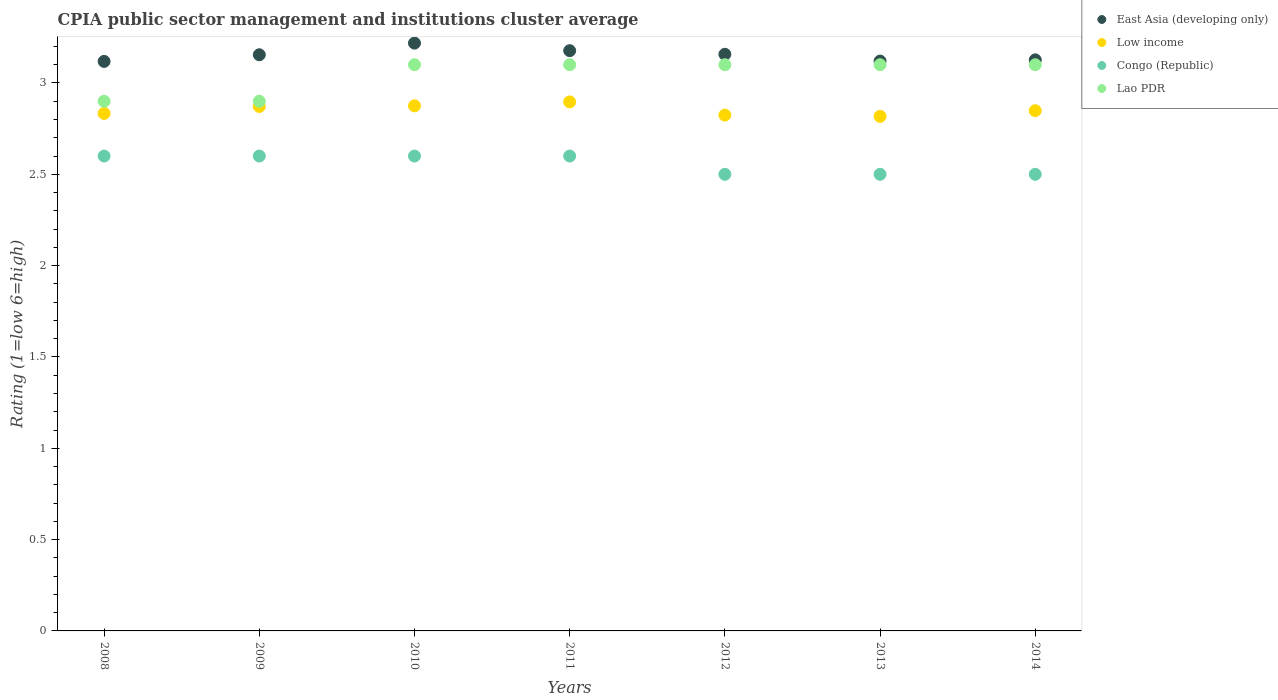How many different coloured dotlines are there?
Offer a terse response. 4. Is the number of dotlines equal to the number of legend labels?
Keep it short and to the point. Yes. What is the CPIA rating in Low income in 2011?
Ensure brevity in your answer.  2.9. Across all years, what is the maximum CPIA rating in Low income?
Give a very brief answer. 2.9. Across all years, what is the minimum CPIA rating in Low income?
Your answer should be compact. 2.82. In which year was the CPIA rating in Congo (Republic) maximum?
Ensure brevity in your answer.  2008. What is the total CPIA rating in Congo (Republic) in the graph?
Give a very brief answer. 17.9. What is the difference between the CPIA rating in East Asia (developing only) in 2011 and that in 2013?
Your response must be concise. 0.06. What is the difference between the CPIA rating in East Asia (developing only) in 2013 and the CPIA rating in Lao PDR in 2009?
Ensure brevity in your answer.  0.22. What is the average CPIA rating in Congo (Republic) per year?
Offer a terse response. 2.56. In the year 2014, what is the difference between the CPIA rating in Congo (Republic) and CPIA rating in Lao PDR?
Your response must be concise. -0.6. In how many years, is the CPIA rating in Lao PDR greater than 1.7?
Give a very brief answer. 7. What is the ratio of the CPIA rating in East Asia (developing only) in 2009 to that in 2014?
Your answer should be compact. 1.01. Is the difference between the CPIA rating in Congo (Republic) in 2008 and 2011 greater than the difference between the CPIA rating in Lao PDR in 2008 and 2011?
Offer a terse response. Yes. What is the difference between the highest and the second highest CPIA rating in East Asia (developing only)?
Offer a very short reply. 0.04. What is the difference between the highest and the lowest CPIA rating in Lao PDR?
Provide a succinct answer. 0.2. Is the sum of the CPIA rating in Low income in 2010 and 2013 greater than the maximum CPIA rating in Congo (Republic) across all years?
Your answer should be compact. Yes. Is it the case that in every year, the sum of the CPIA rating in Low income and CPIA rating in East Asia (developing only)  is greater than the sum of CPIA rating in Lao PDR and CPIA rating in Congo (Republic)?
Provide a short and direct response. No. Is it the case that in every year, the sum of the CPIA rating in Lao PDR and CPIA rating in Congo (Republic)  is greater than the CPIA rating in Low income?
Your response must be concise. Yes. How many years are there in the graph?
Offer a very short reply. 7. What is the difference between two consecutive major ticks on the Y-axis?
Give a very brief answer. 0.5. Are the values on the major ticks of Y-axis written in scientific E-notation?
Your answer should be very brief. No. Does the graph contain grids?
Keep it short and to the point. No. How many legend labels are there?
Make the answer very short. 4. What is the title of the graph?
Make the answer very short. CPIA public sector management and institutions cluster average. Does "San Marino" appear as one of the legend labels in the graph?
Keep it short and to the point. No. What is the Rating (1=low 6=high) in East Asia (developing only) in 2008?
Give a very brief answer. 3.12. What is the Rating (1=low 6=high) of Low income in 2008?
Provide a short and direct response. 2.83. What is the Rating (1=low 6=high) in East Asia (developing only) in 2009?
Keep it short and to the point. 3.15. What is the Rating (1=low 6=high) of Low income in 2009?
Give a very brief answer. 2.87. What is the Rating (1=low 6=high) of Lao PDR in 2009?
Give a very brief answer. 2.9. What is the Rating (1=low 6=high) in East Asia (developing only) in 2010?
Offer a terse response. 3.22. What is the Rating (1=low 6=high) of Low income in 2010?
Offer a terse response. 2.88. What is the Rating (1=low 6=high) in Congo (Republic) in 2010?
Provide a succinct answer. 2.6. What is the Rating (1=low 6=high) of Lao PDR in 2010?
Ensure brevity in your answer.  3.1. What is the Rating (1=low 6=high) of East Asia (developing only) in 2011?
Make the answer very short. 3.18. What is the Rating (1=low 6=high) of Low income in 2011?
Your answer should be compact. 2.9. What is the Rating (1=low 6=high) of Congo (Republic) in 2011?
Keep it short and to the point. 2.6. What is the Rating (1=low 6=high) in East Asia (developing only) in 2012?
Make the answer very short. 3.16. What is the Rating (1=low 6=high) of Low income in 2012?
Provide a short and direct response. 2.82. What is the Rating (1=low 6=high) in Lao PDR in 2012?
Your answer should be compact. 3.1. What is the Rating (1=low 6=high) in East Asia (developing only) in 2013?
Keep it short and to the point. 3.12. What is the Rating (1=low 6=high) of Low income in 2013?
Your response must be concise. 2.82. What is the Rating (1=low 6=high) of East Asia (developing only) in 2014?
Your answer should be very brief. 3.13. What is the Rating (1=low 6=high) in Low income in 2014?
Provide a succinct answer. 2.85. What is the Rating (1=low 6=high) in Congo (Republic) in 2014?
Your answer should be very brief. 2.5. What is the Rating (1=low 6=high) of Lao PDR in 2014?
Your answer should be compact. 3.1. Across all years, what is the maximum Rating (1=low 6=high) of East Asia (developing only)?
Your response must be concise. 3.22. Across all years, what is the maximum Rating (1=low 6=high) of Low income?
Give a very brief answer. 2.9. Across all years, what is the maximum Rating (1=low 6=high) of Congo (Republic)?
Your answer should be very brief. 2.6. Across all years, what is the maximum Rating (1=low 6=high) of Lao PDR?
Your answer should be compact. 3.1. Across all years, what is the minimum Rating (1=low 6=high) in East Asia (developing only)?
Your answer should be compact. 3.12. Across all years, what is the minimum Rating (1=low 6=high) in Low income?
Your response must be concise. 2.82. What is the total Rating (1=low 6=high) in East Asia (developing only) in the graph?
Give a very brief answer. 22.07. What is the total Rating (1=low 6=high) of Low income in the graph?
Ensure brevity in your answer.  19.97. What is the total Rating (1=low 6=high) in Congo (Republic) in the graph?
Make the answer very short. 17.9. What is the total Rating (1=low 6=high) of Lao PDR in the graph?
Give a very brief answer. 21.3. What is the difference between the Rating (1=low 6=high) in East Asia (developing only) in 2008 and that in 2009?
Provide a succinct answer. -0.04. What is the difference between the Rating (1=low 6=high) of Low income in 2008 and that in 2009?
Your answer should be very brief. -0.04. What is the difference between the Rating (1=low 6=high) in Congo (Republic) in 2008 and that in 2009?
Ensure brevity in your answer.  0. What is the difference between the Rating (1=low 6=high) in Lao PDR in 2008 and that in 2009?
Your answer should be compact. 0. What is the difference between the Rating (1=low 6=high) in East Asia (developing only) in 2008 and that in 2010?
Provide a short and direct response. -0.1. What is the difference between the Rating (1=low 6=high) of Low income in 2008 and that in 2010?
Your answer should be very brief. -0.04. What is the difference between the Rating (1=low 6=high) in Congo (Republic) in 2008 and that in 2010?
Offer a terse response. 0. What is the difference between the Rating (1=low 6=high) of East Asia (developing only) in 2008 and that in 2011?
Offer a terse response. -0.06. What is the difference between the Rating (1=low 6=high) of Low income in 2008 and that in 2011?
Offer a terse response. -0.06. What is the difference between the Rating (1=low 6=high) in Congo (Republic) in 2008 and that in 2011?
Offer a very short reply. 0. What is the difference between the Rating (1=low 6=high) in Lao PDR in 2008 and that in 2011?
Make the answer very short. -0.2. What is the difference between the Rating (1=low 6=high) in East Asia (developing only) in 2008 and that in 2012?
Keep it short and to the point. -0.04. What is the difference between the Rating (1=low 6=high) in Low income in 2008 and that in 2012?
Offer a terse response. 0.01. What is the difference between the Rating (1=low 6=high) of Congo (Republic) in 2008 and that in 2012?
Make the answer very short. 0.1. What is the difference between the Rating (1=low 6=high) in Lao PDR in 2008 and that in 2012?
Provide a short and direct response. -0.2. What is the difference between the Rating (1=low 6=high) in East Asia (developing only) in 2008 and that in 2013?
Provide a short and direct response. -0. What is the difference between the Rating (1=low 6=high) of Low income in 2008 and that in 2013?
Your answer should be very brief. 0.02. What is the difference between the Rating (1=low 6=high) in Lao PDR in 2008 and that in 2013?
Your response must be concise. -0.2. What is the difference between the Rating (1=low 6=high) in East Asia (developing only) in 2008 and that in 2014?
Offer a terse response. -0.01. What is the difference between the Rating (1=low 6=high) in Low income in 2008 and that in 2014?
Provide a short and direct response. -0.01. What is the difference between the Rating (1=low 6=high) of Congo (Republic) in 2008 and that in 2014?
Your answer should be very brief. 0.1. What is the difference between the Rating (1=low 6=high) in Lao PDR in 2008 and that in 2014?
Your answer should be very brief. -0.2. What is the difference between the Rating (1=low 6=high) in East Asia (developing only) in 2009 and that in 2010?
Ensure brevity in your answer.  -0.06. What is the difference between the Rating (1=low 6=high) of Low income in 2009 and that in 2010?
Offer a very short reply. -0. What is the difference between the Rating (1=low 6=high) in Congo (Republic) in 2009 and that in 2010?
Offer a terse response. 0. What is the difference between the Rating (1=low 6=high) of East Asia (developing only) in 2009 and that in 2011?
Ensure brevity in your answer.  -0.02. What is the difference between the Rating (1=low 6=high) in Low income in 2009 and that in 2011?
Provide a succinct answer. -0.03. What is the difference between the Rating (1=low 6=high) in Congo (Republic) in 2009 and that in 2011?
Make the answer very short. 0. What is the difference between the Rating (1=low 6=high) of Lao PDR in 2009 and that in 2011?
Provide a short and direct response. -0.2. What is the difference between the Rating (1=low 6=high) in East Asia (developing only) in 2009 and that in 2012?
Your answer should be compact. -0. What is the difference between the Rating (1=low 6=high) of Low income in 2009 and that in 2012?
Offer a terse response. 0.05. What is the difference between the Rating (1=low 6=high) of Congo (Republic) in 2009 and that in 2012?
Ensure brevity in your answer.  0.1. What is the difference between the Rating (1=low 6=high) of East Asia (developing only) in 2009 and that in 2013?
Provide a short and direct response. 0.03. What is the difference between the Rating (1=low 6=high) in Low income in 2009 and that in 2013?
Ensure brevity in your answer.  0.05. What is the difference between the Rating (1=low 6=high) of Congo (Republic) in 2009 and that in 2013?
Offer a very short reply. 0.1. What is the difference between the Rating (1=low 6=high) in East Asia (developing only) in 2009 and that in 2014?
Your answer should be compact. 0.03. What is the difference between the Rating (1=low 6=high) in Low income in 2009 and that in 2014?
Make the answer very short. 0.02. What is the difference between the Rating (1=low 6=high) in Congo (Republic) in 2009 and that in 2014?
Keep it short and to the point. 0.1. What is the difference between the Rating (1=low 6=high) of East Asia (developing only) in 2010 and that in 2011?
Provide a succinct answer. 0.04. What is the difference between the Rating (1=low 6=high) in Low income in 2010 and that in 2011?
Provide a short and direct response. -0.02. What is the difference between the Rating (1=low 6=high) in East Asia (developing only) in 2010 and that in 2012?
Make the answer very short. 0.06. What is the difference between the Rating (1=low 6=high) in Low income in 2010 and that in 2012?
Your response must be concise. 0.05. What is the difference between the Rating (1=low 6=high) in Lao PDR in 2010 and that in 2012?
Ensure brevity in your answer.  0. What is the difference between the Rating (1=low 6=high) in East Asia (developing only) in 2010 and that in 2013?
Provide a short and direct response. 0.1. What is the difference between the Rating (1=low 6=high) of Low income in 2010 and that in 2013?
Provide a succinct answer. 0.06. What is the difference between the Rating (1=low 6=high) in Congo (Republic) in 2010 and that in 2013?
Keep it short and to the point. 0.1. What is the difference between the Rating (1=low 6=high) in Lao PDR in 2010 and that in 2013?
Provide a succinct answer. 0. What is the difference between the Rating (1=low 6=high) in East Asia (developing only) in 2010 and that in 2014?
Give a very brief answer. 0.09. What is the difference between the Rating (1=low 6=high) in Low income in 2010 and that in 2014?
Make the answer very short. 0.03. What is the difference between the Rating (1=low 6=high) in Congo (Republic) in 2010 and that in 2014?
Your answer should be compact. 0.1. What is the difference between the Rating (1=low 6=high) in East Asia (developing only) in 2011 and that in 2012?
Your answer should be compact. 0.02. What is the difference between the Rating (1=low 6=high) of Low income in 2011 and that in 2012?
Ensure brevity in your answer.  0.07. What is the difference between the Rating (1=low 6=high) in Lao PDR in 2011 and that in 2012?
Keep it short and to the point. 0. What is the difference between the Rating (1=low 6=high) in East Asia (developing only) in 2011 and that in 2013?
Provide a succinct answer. 0.06. What is the difference between the Rating (1=low 6=high) in Low income in 2011 and that in 2013?
Keep it short and to the point. 0.08. What is the difference between the Rating (1=low 6=high) in East Asia (developing only) in 2011 and that in 2014?
Make the answer very short. 0.05. What is the difference between the Rating (1=low 6=high) in Low income in 2011 and that in 2014?
Ensure brevity in your answer.  0.05. What is the difference between the Rating (1=low 6=high) in Congo (Republic) in 2011 and that in 2014?
Provide a succinct answer. 0.1. What is the difference between the Rating (1=low 6=high) in Lao PDR in 2011 and that in 2014?
Your answer should be compact. 0. What is the difference between the Rating (1=low 6=high) of East Asia (developing only) in 2012 and that in 2013?
Your answer should be compact. 0.04. What is the difference between the Rating (1=low 6=high) of Low income in 2012 and that in 2013?
Offer a very short reply. 0.01. What is the difference between the Rating (1=low 6=high) in Congo (Republic) in 2012 and that in 2013?
Your answer should be very brief. 0. What is the difference between the Rating (1=low 6=high) of Lao PDR in 2012 and that in 2013?
Make the answer very short. 0. What is the difference between the Rating (1=low 6=high) in East Asia (developing only) in 2012 and that in 2014?
Offer a terse response. 0.03. What is the difference between the Rating (1=low 6=high) in Low income in 2012 and that in 2014?
Your answer should be very brief. -0.02. What is the difference between the Rating (1=low 6=high) in Lao PDR in 2012 and that in 2014?
Provide a succinct answer. 0. What is the difference between the Rating (1=low 6=high) in East Asia (developing only) in 2013 and that in 2014?
Your response must be concise. -0.01. What is the difference between the Rating (1=low 6=high) in Low income in 2013 and that in 2014?
Your answer should be compact. -0.03. What is the difference between the Rating (1=low 6=high) in Congo (Republic) in 2013 and that in 2014?
Make the answer very short. 0. What is the difference between the Rating (1=low 6=high) in East Asia (developing only) in 2008 and the Rating (1=low 6=high) in Low income in 2009?
Your answer should be compact. 0.25. What is the difference between the Rating (1=low 6=high) of East Asia (developing only) in 2008 and the Rating (1=low 6=high) of Congo (Republic) in 2009?
Your response must be concise. 0.52. What is the difference between the Rating (1=low 6=high) in East Asia (developing only) in 2008 and the Rating (1=low 6=high) in Lao PDR in 2009?
Offer a very short reply. 0.22. What is the difference between the Rating (1=low 6=high) of Low income in 2008 and the Rating (1=low 6=high) of Congo (Republic) in 2009?
Your response must be concise. 0.23. What is the difference between the Rating (1=low 6=high) in Low income in 2008 and the Rating (1=low 6=high) in Lao PDR in 2009?
Keep it short and to the point. -0.07. What is the difference between the Rating (1=low 6=high) of Congo (Republic) in 2008 and the Rating (1=low 6=high) of Lao PDR in 2009?
Ensure brevity in your answer.  -0.3. What is the difference between the Rating (1=low 6=high) in East Asia (developing only) in 2008 and the Rating (1=low 6=high) in Low income in 2010?
Make the answer very short. 0.24. What is the difference between the Rating (1=low 6=high) of East Asia (developing only) in 2008 and the Rating (1=low 6=high) of Congo (Republic) in 2010?
Your answer should be compact. 0.52. What is the difference between the Rating (1=low 6=high) in East Asia (developing only) in 2008 and the Rating (1=low 6=high) in Lao PDR in 2010?
Make the answer very short. 0.02. What is the difference between the Rating (1=low 6=high) in Low income in 2008 and the Rating (1=low 6=high) in Congo (Republic) in 2010?
Your response must be concise. 0.23. What is the difference between the Rating (1=low 6=high) of Low income in 2008 and the Rating (1=low 6=high) of Lao PDR in 2010?
Make the answer very short. -0.27. What is the difference between the Rating (1=low 6=high) of East Asia (developing only) in 2008 and the Rating (1=low 6=high) of Low income in 2011?
Give a very brief answer. 0.22. What is the difference between the Rating (1=low 6=high) of East Asia (developing only) in 2008 and the Rating (1=low 6=high) of Congo (Republic) in 2011?
Your answer should be very brief. 0.52. What is the difference between the Rating (1=low 6=high) in East Asia (developing only) in 2008 and the Rating (1=low 6=high) in Lao PDR in 2011?
Provide a short and direct response. 0.02. What is the difference between the Rating (1=low 6=high) of Low income in 2008 and the Rating (1=low 6=high) of Congo (Republic) in 2011?
Provide a succinct answer. 0.23. What is the difference between the Rating (1=low 6=high) of Low income in 2008 and the Rating (1=low 6=high) of Lao PDR in 2011?
Your response must be concise. -0.27. What is the difference between the Rating (1=low 6=high) of East Asia (developing only) in 2008 and the Rating (1=low 6=high) of Low income in 2012?
Your response must be concise. 0.29. What is the difference between the Rating (1=low 6=high) of East Asia (developing only) in 2008 and the Rating (1=low 6=high) of Congo (Republic) in 2012?
Provide a short and direct response. 0.62. What is the difference between the Rating (1=low 6=high) in East Asia (developing only) in 2008 and the Rating (1=low 6=high) in Lao PDR in 2012?
Your answer should be compact. 0.02. What is the difference between the Rating (1=low 6=high) in Low income in 2008 and the Rating (1=low 6=high) in Congo (Republic) in 2012?
Provide a short and direct response. 0.33. What is the difference between the Rating (1=low 6=high) in Low income in 2008 and the Rating (1=low 6=high) in Lao PDR in 2012?
Your response must be concise. -0.27. What is the difference between the Rating (1=low 6=high) in Congo (Republic) in 2008 and the Rating (1=low 6=high) in Lao PDR in 2012?
Keep it short and to the point. -0.5. What is the difference between the Rating (1=low 6=high) in East Asia (developing only) in 2008 and the Rating (1=low 6=high) in Low income in 2013?
Make the answer very short. 0.3. What is the difference between the Rating (1=low 6=high) in East Asia (developing only) in 2008 and the Rating (1=low 6=high) in Congo (Republic) in 2013?
Your answer should be very brief. 0.62. What is the difference between the Rating (1=low 6=high) of East Asia (developing only) in 2008 and the Rating (1=low 6=high) of Lao PDR in 2013?
Provide a succinct answer. 0.02. What is the difference between the Rating (1=low 6=high) in Low income in 2008 and the Rating (1=low 6=high) in Lao PDR in 2013?
Keep it short and to the point. -0.27. What is the difference between the Rating (1=low 6=high) in Congo (Republic) in 2008 and the Rating (1=low 6=high) in Lao PDR in 2013?
Give a very brief answer. -0.5. What is the difference between the Rating (1=low 6=high) of East Asia (developing only) in 2008 and the Rating (1=low 6=high) of Low income in 2014?
Make the answer very short. 0.27. What is the difference between the Rating (1=low 6=high) in East Asia (developing only) in 2008 and the Rating (1=low 6=high) in Congo (Republic) in 2014?
Ensure brevity in your answer.  0.62. What is the difference between the Rating (1=low 6=high) in East Asia (developing only) in 2008 and the Rating (1=low 6=high) in Lao PDR in 2014?
Make the answer very short. 0.02. What is the difference between the Rating (1=low 6=high) of Low income in 2008 and the Rating (1=low 6=high) of Lao PDR in 2014?
Offer a terse response. -0.27. What is the difference between the Rating (1=low 6=high) of Congo (Republic) in 2008 and the Rating (1=low 6=high) of Lao PDR in 2014?
Your answer should be compact. -0.5. What is the difference between the Rating (1=low 6=high) in East Asia (developing only) in 2009 and the Rating (1=low 6=high) in Low income in 2010?
Your answer should be compact. 0.28. What is the difference between the Rating (1=low 6=high) of East Asia (developing only) in 2009 and the Rating (1=low 6=high) of Congo (Republic) in 2010?
Keep it short and to the point. 0.55. What is the difference between the Rating (1=low 6=high) in East Asia (developing only) in 2009 and the Rating (1=low 6=high) in Lao PDR in 2010?
Offer a very short reply. 0.05. What is the difference between the Rating (1=low 6=high) in Low income in 2009 and the Rating (1=low 6=high) in Congo (Republic) in 2010?
Keep it short and to the point. 0.27. What is the difference between the Rating (1=low 6=high) in Low income in 2009 and the Rating (1=low 6=high) in Lao PDR in 2010?
Your answer should be compact. -0.23. What is the difference between the Rating (1=low 6=high) in East Asia (developing only) in 2009 and the Rating (1=low 6=high) in Low income in 2011?
Offer a terse response. 0.26. What is the difference between the Rating (1=low 6=high) of East Asia (developing only) in 2009 and the Rating (1=low 6=high) of Congo (Republic) in 2011?
Your answer should be very brief. 0.55. What is the difference between the Rating (1=low 6=high) in East Asia (developing only) in 2009 and the Rating (1=low 6=high) in Lao PDR in 2011?
Give a very brief answer. 0.05. What is the difference between the Rating (1=low 6=high) in Low income in 2009 and the Rating (1=low 6=high) in Congo (Republic) in 2011?
Provide a short and direct response. 0.27. What is the difference between the Rating (1=low 6=high) in Low income in 2009 and the Rating (1=low 6=high) in Lao PDR in 2011?
Your answer should be compact. -0.23. What is the difference between the Rating (1=low 6=high) of East Asia (developing only) in 2009 and the Rating (1=low 6=high) of Low income in 2012?
Make the answer very short. 0.33. What is the difference between the Rating (1=low 6=high) of East Asia (developing only) in 2009 and the Rating (1=low 6=high) of Congo (Republic) in 2012?
Make the answer very short. 0.65. What is the difference between the Rating (1=low 6=high) in East Asia (developing only) in 2009 and the Rating (1=low 6=high) in Lao PDR in 2012?
Your answer should be very brief. 0.05. What is the difference between the Rating (1=low 6=high) of Low income in 2009 and the Rating (1=low 6=high) of Congo (Republic) in 2012?
Offer a terse response. 0.37. What is the difference between the Rating (1=low 6=high) in Low income in 2009 and the Rating (1=low 6=high) in Lao PDR in 2012?
Keep it short and to the point. -0.23. What is the difference between the Rating (1=low 6=high) of East Asia (developing only) in 2009 and the Rating (1=low 6=high) of Low income in 2013?
Keep it short and to the point. 0.34. What is the difference between the Rating (1=low 6=high) in East Asia (developing only) in 2009 and the Rating (1=low 6=high) in Congo (Republic) in 2013?
Offer a very short reply. 0.65. What is the difference between the Rating (1=low 6=high) in East Asia (developing only) in 2009 and the Rating (1=low 6=high) in Lao PDR in 2013?
Your response must be concise. 0.05. What is the difference between the Rating (1=low 6=high) in Low income in 2009 and the Rating (1=low 6=high) in Congo (Republic) in 2013?
Provide a succinct answer. 0.37. What is the difference between the Rating (1=low 6=high) in Low income in 2009 and the Rating (1=low 6=high) in Lao PDR in 2013?
Offer a terse response. -0.23. What is the difference between the Rating (1=low 6=high) in Congo (Republic) in 2009 and the Rating (1=low 6=high) in Lao PDR in 2013?
Ensure brevity in your answer.  -0.5. What is the difference between the Rating (1=low 6=high) in East Asia (developing only) in 2009 and the Rating (1=low 6=high) in Low income in 2014?
Your answer should be very brief. 0.31. What is the difference between the Rating (1=low 6=high) in East Asia (developing only) in 2009 and the Rating (1=low 6=high) in Congo (Republic) in 2014?
Your response must be concise. 0.65. What is the difference between the Rating (1=low 6=high) in East Asia (developing only) in 2009 and the Rating (1=low 6=high) in Lao PDR in 2014?
Ensure brevity in your answer.  0.05. What is the difference between the Rating (1=low 6=high) of Low income in 2009 and the Rating (1=low 6=high) of Congo (Republic) in 2014?
Make the answer very short. 0.37. What is the difference between the Rating (1=low 6=high) in Low income in 2009 and the Rating (1=low 6=high) in Lao PDR in 2014?
Ensure brevity in your answer.  -0.23. What is the difference between the Rating (1=low 6=high) in East Asia (developing only) in 2010 and the Rating (1=low 6=high) in Low income in 2011?
Provide a succinct answer. 0.32. What is the difference between the Rating (1=low 6=high) in East Asia (developing only) in 2010 and the Rating (1=low 6=high) in Congo (Republic) in 2011?
Ensure brevity in your answer.  0.62. What is the difference between the Rating (1=low 6=high) in East Asia (developing only) in 2010 and the Rating (1=low 6=high) in Lao PDR in 2011?
Provide a succinct answer. 0.12. What is the difference between the Rating (1=low 6=high) in Low income in 2010 and the Rating (1=low 6=high) in Congo (Republic) in 2011?
Keep it short and to the point. 0.28. What is the difference between the Rating (1=low 6=high) of Low income in 2010 and the Rating (1=low 6=high) of Lao PDR in 2011?
Offer a very short reply. -0.23. What is the difference between the Rating (1=low 6=high) in East Asia (developing only) in 2010 and the Rating (1=low 6=high) in Low income in 2012?
Keep it short and to the point. 0.39. What is the difference between the Rating (1=low 6=high) in East Asia (developing only) in 2010 and the Rating (1=low 6=high) in Congo (Republic) in 2012?
Give a very brief answer. 0.72. What is the difference between the Rating (1=low 6=high) of East Asia (developing only) in 2010 and the Rating (1=low 6=high) of Lao PDR in 2012?
Make the answer very short. 0.12. What is the difference between the Rating (1=low 6=high) of Low income in 2010 and the Rating (1=low 6=high) of Congo (Republic) in 2012?
Provide a succinct answer. 0.38. What is the difference between the Rating (1=low 6=high) in Low income in 2010 and the Rating (1=low 6=high) in Lao PDR in 2012?
Your response must be concise. -0.23. What is the difference between the Rating (1=low 6=high) of East Asia (developing only) in 2010 and the Rating (1=low 6=high) of Low income in 2013?
Give a very brief answer. 0.4. What is the difference between the Rating (1=low 6=high) of East Asia (developing only) in 2010 and the Rating (1=low 6=high) of Congo (Republic) in 2013?
Offer a very short reply. 0.72. What is the difference between the Rating (1=low 6=high) of East Asia (developing only) in 2010 and the Rating (1=low 6=high) of Lao PDR in 2013?
Your answer should be very brief. 0.12. What is the difference between the Rating (1=low 6=high) of Low income in 2010 and the Rating (1=low 6=high) of Congo (Republic) in 2013?
Your answer should be very brief. 0.38. What is the difference between the Rating (1=low 6=high) in Low income in 2010 and the Rating (1=low 6=high) in Lao PDR in 2013?
Ensure brevity in your answer.  -0.23. What is the difference between the Rating (1=low 6=high) in Congo (Republic) in 2010 and the Rating (1=low 6=high) in Lao PDR in 2013?
Provide a short and direct response. -0.5. What is the difference between the Rating (1=low 6=high) of East Asia (developing only) in 2010 and the Rating (1=low 6=high) of Low income in 2014?
Ensure brevity in your answer.  0.37. What is the difference between the Rating (1=low 6=high) in East Asia (developing only) in 2010 and the Rating (1=low 6=high) in Congo (Republic) in 2014?
Keep it short and to the point. 0.72. What is the difference between the Rating (1=low 6=high) of East Asia (developing only) in 2010 and the Rating (1=low 6=high) of Lao PDR in 2014?
Your answer should be compact. 0.12. What is the difference between the Rating (1=low 6=high) of Low income in 2010 and the Rating (1=low 6=high) of Congo (Republic) in 2014?
Give a very brief answer. 0.38. What is the difference between the Rating (1=low 6=high) of Low income in 2010 and the Rating (1=low 6=high) of Lao PDR in 2014?
Provide a succinct answer. -0.23. What is the difference between the Rating (1=low 6=high) of Congo (Republic) in 2010 and the Rating (1=low 6=high) of Lao PDR in 2014?
Offer a terse response. -0.5. What is the difference between the Rating (1=low 6=high) in East Asia (developing only) in 2011 and the Rating (1=low 6=high) in Low income in 2012?
Keep it short and to the point. 0.35. What is the difference between the Rating (1=low 6=high) of East Asia (developing only) in 2011 and the Rating (1=low 6=high) of Congo (Republic) in 2012?
Offer a terse response. 0.68. What is the difference between the Rating (1=low 6=high) of East Asia (developing only) in 2011 and the Rating (1=low 6=high) of Lao PDR in 2012?
Keep it short and to the point. 0.08. What is the difference between the Rating (1=low 6=high) of Low income in 2011 and the Rating (1=low 6=high) of Congo (Republic) in 2012?
Offer a very short reply. 0.4. What is the difference between the Rating (1=low 6=high) of Low income in 2011 and the Rating (1=low 6=high) of Lao PDR in 2012?
Ensure brevity in your answer.  -0.2. What is the difference between the Rating (1=low 6=high) in East Asia (developing only) in 2011 and the Rating (1=low 6=high) in Low income in 2013?
Your answer should be compact. 0.36. What is the difference between the Rating (1=low 6=high) of East Asia (developing only) in 2011 and the Rating (1=low 6=high) of Congo (Republic) in 2013?
Keep it short and to the point. 0.68. What is the difference between the Rating (1=low 6=high) in East Asia (developing only) in 2011 and the Rating (1=low 6=high) in Lao PDR in 2013?
Offer a terse response. 0.08. What is the difference between the Rating (1=low 6=high) of Low income in 2011 and the Rating (1=low 6=high) of Congo (Republic) in 2013?
Keep it short and to the point. 0.4. What is the difference between the Rating (1=low 6=high) in Low income in 2011 and the Rating (1=low 6=high) in Lao PDR in 2013?
Your response must be concise. -0.2. What is the difference between the Rating (1=low 6=high) in Congo (Republic) in 2011 and the Rating (1=low 6=high) in Lao PDR in 2013?
Offer a terse response. -0.5. What is the difference between the Rating (1=low 6=high) in East Asia (developing only) in 2011 and the Rating (1=low 6=high) in Low income in 2014?
Your answer should be compact. 0.33. What is the difference between the Rating (1=low 6=high) of East Asia (developing only) in 2011 and the Rating (1=low 6=high) of Congo (Republic) in 2014?
Offer a terse response. 0.68. What is the difference between the Rating (1=low 6=high) of East Asia (developing only) in 2011 and the Rating (1=low 6=high) of Lao PDR in 2014?
Offer a terse response. 0.08. What is the difference between the Rating (1=low 6=high) of Low income in 2011 and the Rating (1=low 6=high) of Congo (Republic) in 2014?
Make the answer very short. 0.4. What is the difference between the Rating (1=low 6=high) in Low income in 2011 and the Rating (1=low 6=high) in Lao PDR in 2014?
Offer a very short reply. -0.2. What is the difference between the Rating (1=low 6=high) in Congo (Republic) in 2011 and the Rating (1=low 6=high) in Lao PDR in 2014?
Give a very brief answer. -0.5. What is the difference between the Rating (1=low 6=high) of East Asia (developing only) in 2012 and the Rating (1=low 6=high) of Low income in 2013?
Offer a terse response. 0.34. What is the difference between the Rating (1=low 6=high) of East Asia (developing only) in 2012 and the Rating (1=low 6=high) of Congo (Republic) in 2013?
Ensure brevity in your answer.  0.66. What is the difference between the Rating (1=low 6=high) of East Asia (developing only) in 2012 and the Rating (1=low 6=high) of Lao PDR in 2013?
Ensure brevity in your answer.  0.06. What is the difference between the Rating (1=low 6=high) in Low income in 2012 and the Rating (1=low 6=high) in Congo (Republic) in 2013?
Keep it short and to the point. 0.32. What is the difference between the Rating (1=low 6=high) of Low income in 2012 and the Rating (1=low 6=high) of Lao PDR in 2013?
Provide a short and direct response. -0.28. What is the difference between the Rating (1=low 6=high) of Congo (Republic) in 2012 and the Rating (1=low 6=high) of Lao PDR in 2013?
Offer a terse response. -0.6. What is the difference between the Rating (1=low 6=high) in East Asia (developing only) in 2012 and the Rating (1=low 6=high) in Low income in 2014?
Ensure brevity in your answer.  0.31. What is the difference between the Rating (1=low 6=high) in East Asia (developing only) in 2012 and the Rating (1=low 6=high) in Congo (Republic) in 2014?
Provide a short and direct response. 0.66. What is the difference between the Rating (1=low 6=high) in East Asia (developing only) in 2012 and the Rating (1=low 6=high) in Lao PDR in 2014?
Ensure brevity in your answer.  0.06. What is the difference between the Rating (1=low 6=high) of Low income in 2012 and the Rating (1=low 6=high) of Congo (Republic) in 2014?
Your answer should be compact. 0.32. What is the difference between the Rating (1=low 6=high) in Low income in 2012 and the Rating (1=low 6=high) in Lao PDR in 2014?
Offer a very short reply. -0.28. What is the difference between the Rating (1=low 6=high) in Congo (Republic) in 2012 and the Rating (1=low 6=high) in Lao PDR in 2014?
Your answer should be very brief. -0.6. What is the difference between the Rating (1=low 6=high) in East Asia (developing only) in 2013 and the Rating (1=low 6=high) in Low income in 2014?
Give a very brief answer. 0.27. What is the difference between the Rating (1=low 6=high) of East Asia (developing only) in 2013 and the Rating (1=low 6=high) of Congo (Republic) in 2014?
Your response must be concise. 0.62. What is the difference between the Rating (1=low 6=high) of Low income in 2013 and the Rating (1=low 6=high) of Congo (Republic) in 2014?
Ensure brevity in your answer.  0.32. What is the difference between the Rating (1=low 6=high) in Low income in 2013 and the Rating (1=low 6=high) in Lao PDR in 2014?
Provide a succinct answer. -0.28. What is the average Rating (1=low 6=high) in East Asia (developing only) per year?
Provide a succinct answer. 3.15. What is the average Rating (1=low 6=high) in Low income per year?
Your response must be concise. 2.85. What is the average Rating (1=low 6=high) of Congo (Republic) per year?
Offer a terse response. 2.56. What is the average Rating (1=low 6=high) in Lao PDR per year?
Ensure brevity in your answer.  3.04. In the year 2008, what is the difference between the Rating (1=low 6=high) of East Asia (developing only) and Rating (1=low 6=high) of Low income?
Offer a very short reply. 0.28. In the year 2008, what is the difference between the Rating (1=low 6=high) in East Asia (developing only) and Rating (1=low 6=high) in Congo (Republic)?
Give a very brief answer. 0.52. In the year 2008, what is the difference between the Rating (1=low 6=high) in East Asia (developing only) and Rating (1=low 6=high) in Lao PDR?
Provide a succinct answer. 0.22. In the year 2008, what is the difference between the Rating (1=low 6=high) in Low income and Rating (1=low 6=high) in Congo (Republic)?
Keep it short and to the point. 0.23. In the year 2008, what is the difference between the Rating (1=low 6=high) in Low income and Rating (1=low 6=high) in Lao PDR?
Your answer should be very brief. -0.07. In the year 2008, what is the difference between the Rating (1=low 6=high) of Congo (Republic) and Rating (1=low 6=high) of Lao PDR?
Ensure brevity in your answer.  -0.3. In the year 2009, what is the difference between the Rating (1=low 6=high) in East Asia (developing only) and Rating (1=low 6=high) in Low income?
Ensure brevity in your answer.  0.28. In the year 2009, what is the difference between the Rating (1=low 6=high) of East Asia (developing only) and Rating (1=low 6=high) of Congo (Republic)?
Ensure brevity in your answer.  0.55. In the year 2009, what is the difference between the Rating (1=low 6=high) of East Asia (developing only) and Rating (1=low 6=high) of Lao PDR?
Ensure brevity in your answer.  0.25. In the year 2009, what is the difference between the Rating (1=low 6=high) in Low income and Rating (1=low 6=high) in Congo (Republic)?
Offer a terse response. 0.27. In the year 2009, what is the difference between the Rating (1=low 6=high) of Low income and Rating (1=low 6=high) of Lao PDR?
Offer a terse response. -0.03. In the year 2010, what is the difference between the Rating (1=low 6=high) of East Asia (developing only) and Rating (1=low 6=high) of Low income?
Give a very brief answer. 0.34. In the year 2010, what is the difference between the Rating (1=low 6=high) of East Asia (developing only) and Rating (1=low 6=high) of Congo (Republic)?
Offer a very short reply. 0.62. In the year 2010, what is the difference between the Rating (1=low 6=high) of East Asia (developing only) and Rating (1=low 6=high) of Lao PDR?
Ensure brevity in your answer.  0.12. In the year 2010, what is the difference between the Rating (1=low 6=high) of Low income and Rating (1=low 6=high) of Congo (Republic)?
Provide a short and direct response. 0.28. In the year 2010, what is the difference between the Rating (1=low 6=high) in Low income and Rating (1=low 6=high) in Lao PDR?
Ensure brevity in your answer.  -0.23. In the year 2011, what is the difference between the Rating (1=low 6=high) in East Asia (developing only) and Rating (1=low 6=high) in Low income?
Your answer should be very brief. 0.28. In the year 2011, what is the difference between the Rating (1=low 6=high) of East Asia (developing only) and Rating (1=low 6=high) of Congo (Republic)?
Your answer should be very brief. 0.58. In the year 2011, what is the difference between the Rating (1=low 6=high) in East Asia (developing only) and Rating (1=low 6=high) in Lao PDR?
Offer a very short reply. 0.08. In the year 2011, what is the difference between the Rating (1=low 6=high) in Low income and Rating (1=low 6=high) in Congo (Republic)?
Offer a terse response. 0.3. In the year 2011, what is the difference between the Rating (1=low 6=high) of Low income and Rating (1=low 6=high) of Lao PDR?
Your answer should be very brief. -0.2. In the year 2011, what is the difference between the Rating (1=low 6=high) in Congo (Republic) and Rating (1=low 6=high) in Lao PDR?
Ensure brevity in your answer.  -0.5. In the year 2012, what is the difference between the Rating (1=low 6=high) in East Asia (developing only) and Rating (1=low 6=high) in Low income?
Your response must be concise. 0.33. In the year 2012, what is the difference between the Rating (1=low 6=high) in East Asia (developing only) and Rating (1=low 6=high) in Congo (Republic)?
Ensure brevity in your answer.  0.66. In the year 2012, what is the difference between the Rating (1=low 6=high) in East Asia (developing only) and Rating (1=low 6=high) in Lao PDR?
Your answer should be compact. 0.06. In the year 2012, what is the difference between the Rating (1=low 6=high) in Low income and Rating (1=low 6=high) in Congo (Republic)?
Your answer should be very brief. 0.32. In the year 2012, what is the difference between the Rating (1=low 6=high) in Low income and Rating (1=low 6=high) in Lao PDR?
Provide a succinct answer. -0.28. In the year 2013, what is the difference between the Rating (1=low 6=high) of East Asia (developing only) and Rating (1=low 6=high) of Low income?
Your response must be concise. 0.3. In the year 2013, what is the difference between the Rating (1=low 6=high) in East Asia (developing only) and Rating (1=low 6=high) in Congo (Republic)?
Your answer should be very brief. 0.62. In the year 2013, what is the difference between the Rating (1=low 6=high) in Low income and Rating (1=low 6=high) in Congo (Republic)?
Offer a very short reply. 0.32. In the year 2013, what is the difference between the Rating (1=low 6=high) of Low income and Rating (1=low 6=high) of Lao PDR?
Make the answer very short. -0.28. In the year 2013, what is the difference between the Rating (1=low 6=high) of Congo (Republic) and Rating (1=low 6=high) of Lao PDR?
Provide a succinct answer. -0.6. In the year 2014, what is the difference between the Rating (1=low 6=high) of East Asia (developing only) and Rating (1=low 6=high) of Low income?
Keep it short and to the point. 0.28. In the year 2014, what is the difference between the Rating (1=low 6=high) of East Asia (developing only) and Rating (1=low 6=high) of Congo (Republic)?
Give a very brief answer. 0.63. In the year 2014, what is the difference between the Rating (1=low 6=high) of East Asia (developing only) and Rating (1=low 6=high) of Lao PDR?
Provide a succinct answer. 0.03. In the year 2014, what is the difference between the Rating (1=low 6=high) in Low income and Rating (1=low 6=high) in Congo (Republic)?
Keep it short and to the point. 0.35. In the year 2014, what is the difference between the Rating (1=low 6=high) in Low income and Rating (1=low 6=high) in Lao PDR?
Your answer should be compact. -0.25. In the year 2014, what is the difference between the Rating (1=low 6=high) in Congo (Republic) and Rating (1=low 6=high) in Lao PDR?
Give a very brief answer. -0.6. What is the ratio of the Rating (1=low 6=high) in Low income in 2008 to that in 2009?
Make the answer very short. 0.99. What is the ratio of the Rating (1=low 6=high) in Congo (Republic) in 2008 to that in 2009?
Your answer should be very brief. 1. What is the ratio of the Rating (1=low 6=high) in Lao PDR in 2008 to that in 2009?
Provide a succinct answer. 1. What is the ratio of the Rating (1=low 6=high) in East Asia (developing only) in 2008 to that in 2010?
Offer a terse response. 0.97. What is the ratio of the Rating (1=low 6=high) of Low income in 2008 to that in 2010?
Keep it short and to the point. 0.99. What is the ratio of the Rating (1=low 6=high) of Congo (Republic) in 2008 to that in 2010?
Give a very brief answer. 1. What is the ratio of the Rating (1=low 6=high) in Lao PDR in 2008 to that in 2010?
Your response must be concise. 0.94. What is the ratio of the Rating (1=low 6=high) of East Asia (developing only) in 2008 to that in 2011?
Offer a terse response. 0.98. What is the ratio of the Rating (1=low 6=high) of Low income in 2008 to that in 2011?
Provide a short and direct response. 0.98. What is the ratio of the Rating (1=low 6=high) of Congo (Republic) in 2008 to that in 2011?
Your answer should be very brief. 1. What is the ratio of the Rating (1=low 6=high) in Lao PDR in 2008 to that in 2011?
Provide a short and direct response. 0.94. What is the ratio of the Rating (1=low 6=high) in East Asia (developing only) in 2008 to that in 2012?
Make the answer very short. 0.99. What is the ratio of the Rating (1=low 6=high) in Lao PDR in 2008 to that in 2012?
Give a very brief answer. 0.94. What is the ratio of the Rating (1=low 6=high) in Lao PDR in 2008 to that in 2013?
Give a very brief answer. 0.94. What is the ratio of the Rating (1=low 6=high) in East Asia (developing only) in 2008 to that in 2014?
Keep it short and to the point. 1. What is the ratio of the Rating (1=low 6=high) in Lao PDR in 2008 to that in 2014?
Offer a very short reply. 0.94. What is the ratio of the Rating (1=low 6=high) in East Asia (developing only) in 2009 to that in 2010?
Provide a short and direct response. 0.98. What is the ratio of the Rating (1=low 6=high) of Lao PDR in 2009 to that in 2010?
Provide a succinct answer. 0.94. What is the ratio of the Rating (1=low 6=high) in East Asia (developing only) in 2009 to that in 2011?
Offer a terse response. 0.99. What is the ratio of the Rating (1=low 6=high) in Low income in 2009 to that in 2011?
Your answer should be compact. 0.99. What is the ratio of the Rating (1=low 6=high) in Congo (Republic) in 2009 to that in 2011?
Give a very brief answer. 1. What is the ratio of the Rating (1=low 6=high) of Lao PDR in 2009 to that in 2011?
Provide a short and direct response. 0.94. What is the ratio of the Rating (1=low 6=high) of East Asia (developing only) in 2009 to that in 2012?
Keep it short and to the point. 1. What is the ratio of the Rating (1=low 6=high) of Low income in 2009 to that in 2012?
Make the answer very short. 1.02. What is the ratio of the Rating (1=low 6=high) of Lao PDR in 2009 to that in 2012?
Your answer should be compact. 0.94. What is the ratio of the Rating (1=low 6=high) of East Asia (developing only) in 2009 to that in 2013?
Your response must be concise. 1.01. What is the ratio of the Rating (1=low 6=high) of Low income in 2009 to that in 2013?
Provide a short and direct response. 1.02. What is the ratio of the Rating (1=low 6=high) of Congo (Republic) in 2009 to that in 2013?
Your answer should be compact. 1.04. What is the ratio of the Rating (1=low 6=high) of Lao PDR in 2009 to that in 2013?
Your answer should be compact. 0.94. What is the ratio of the Rating (1=low 6=high) of East Asia (developing only) in 2009 to that in 2014?
Give a very brief answer. 1.01. What is the ratio of the Rating (1=low 6=high) in Low income in 2009 to that in 2014?
Provide a succinct answer. 1.01. What is the ratio of the Rating (1=low 6=high) of Congo (Republic) in 2009 to that in 2014?
Keep it short and to the point. 1.04. What is the ratio of the Rating (1=low 6=high) of Lao PDR in 2009 to that in 2014?
Keep it short and to the point. 0.94. What is the ratio of the Rating (1=low 6=high) of East Asia (developing only) in 2010 to that in 2011?
Offer a very short reply. 1.01. What is the ratio of the Rating (1=low 6=high) in Lao PDR in 2010 to that in 2011?
Offer a terse response. 1. What is the ratio of the Rating (1=low 6=high) of East Asia (developing only) in 2010 to that in 2012?
Give a very brief answer. 1.02. What is the ratio of the Rating (1=low 6=high) in Low income in 2010 to that in 2012?
Provide a succinct answer. 1.02. What is the ratio of the Rating (1=low 6=high) of Congo (Republic) in 2010 to that in 2012?
Offer a very short reply. 1.04. What is the ratio of the Rating (1=low 6=high) in East Asia (developing only) in 2010 to that in 2013?
Your answer should be compact. 1.03. What is the ratio of the Rating (1=low 6=high) of Low income in 2010 to that in 2013?
Make the answer very short. 1.02. What is the ratio of the Rating (1=low 6=high) of East Asia (developing only) in 2010 to that in 2014?
Offer a very short reply. 1.03. What is the ratio of the Rating (1=low 6=high) of Low income in 2010 to that in 2014?
Keep it short and to the point. 1.01. What is the ratio of the Rating (1=low 6=high) in Low income in 2011 to that in 2012?
Provide a short and direct response. 1.03. What is the ratio of the Rating (1=low 6=high) in East Asia (developing only) in 2011 to that in 2013?
Provide a short and direct response. 1.02. What is the ratio of the Rating (1=low 6=high) of Low income in 2011 to that in 2013?
Provide a succinct answer. 1.03. What is the ratio of the Rating (1=low 6=high) of Lao PDR in 2011 to that in 2013?
Provide a succinct answer. 1. What is the ratio of the Rating (1=low 6=high) of East Asia (developing only) in 2011 to that in 2014?
Your answer should be compact. 1.02. What is the ratio of the Rating (1=low 6=high) in Low income in 2011 to that in 2014?
Your answer should be compact. 1.02. What is the ratio of the Rating (1=low 6=high) of Congo (Republic) in 2011 to that in 2014?
Ensure brevity in your answer.  1.04. What is the ratio of the Rating (1=low 6=high) of East Asia (developing only) in 2012 to that in 2013?
Provide a succinct answer. 1.01. What is the ratio of the Rating (1=low 6=high) in Low income in 2012 to that in 2013?
Make the answer very short. 1. What is the ratio of the Rating (1=low 6=high) of Congo (Republic) in 2012 to that in 2013?
Provide a short and direct response. 1. What is the ratio of the Rating (1=low 6=high) of Lao PDR in 2012 to that in 2013?
Provide a succinct answer. 1. What is the ratio of the Rating (1=low 6=high) of East Asia (developing only) in 2012 to that in 2014?
Give a very brief answer. 1.01. What is the ratio of the Rating (1=low 6=high) of Low income in 2012 to that in 2014?
Provide a succinct answer. 0.99. What is the ratio of the Rating (1=low 6=high) in East Asia (developing only) in 2013 to that in 2014?
Offer a very short reply. 1. What is the difference between the highest and the second highest Rating (1=low 6=high) of East Asia (developing only)?
Make the answer very short. 0.04. What is the difference between the highest and the second highest Rating (1=low 6=high) of Low income?
Ensure brevity in your answer.  0.02. What is the difference between the highest and the lowest Rating (1=low 6=high) in Low income?
Your answer should be compact. 0.08. What is the difference between the highest and the lowest Rating (1=low 6=high) in Lao PDR?
Ensure brevity in your answer.  0.2. 